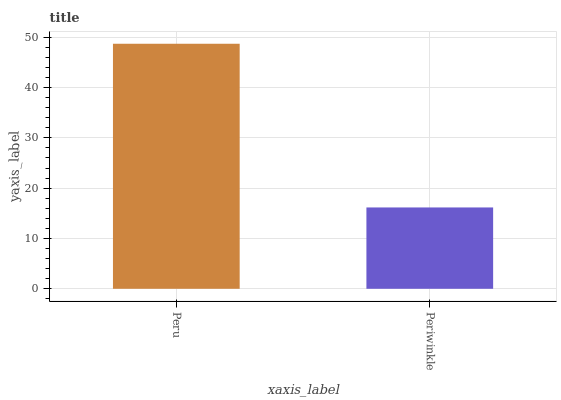Is Periwinkle the minimum?
Answer yes or no. Yes. Is Peru the maximum?
Answer yes or no. Yes. Is Periwinkle the maximum?
Answer yes or no. No. Is Peru greater than Periwinkle?
Answer yes or no. Yes. Is Periwinkle less than Peru?
Answer yes or no. Yes. Is Periwinkle greater than Peru?
Answer yes or no. No. Is Peru less than Periwinkle?
Answer yes or no. No. Is Peru the high median?
Answer yes or no. Yes. Is Periwinkle the low median?
Answer yes or no. Yes. Is Periwinkle the high median?
Answer yes or no. No. Is Peru the low median?
Answer yes or no. No. 